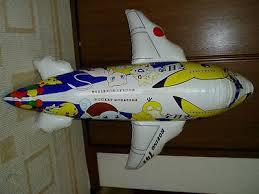What kind of toy is depicted in the image? The image shows a toy airplane, designed with vibrant colors and playful patterns, making it an attractive item for kids. 